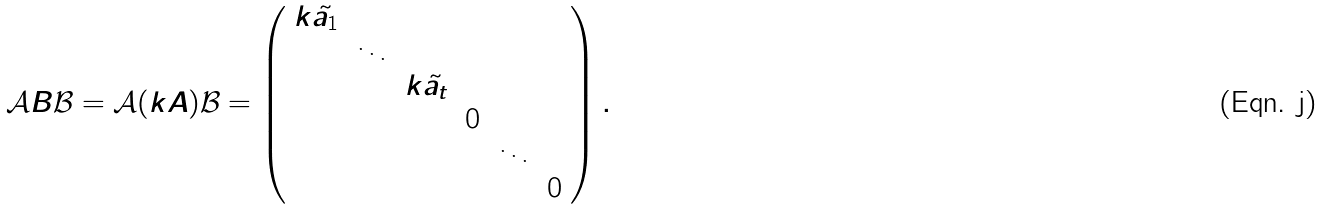Convert formula to latex. <formula><loc_0><loc_0><loc_500><loc_500>\mathcal { A } B \mathcal { B } = \mathcal { A } ( k A ) \mathcal { B } = \left ( \begin{array} { c c c c c c c } k \tilde { a _ { 1 } } & & & & & \\ & \ddots & & & & \\ & & k \tilde { a _ { t } } & & & \\ & & & 0 & & \\ & & & & \ddots & \\ & & & & & 0 \end{array} \right ) .</formula> 